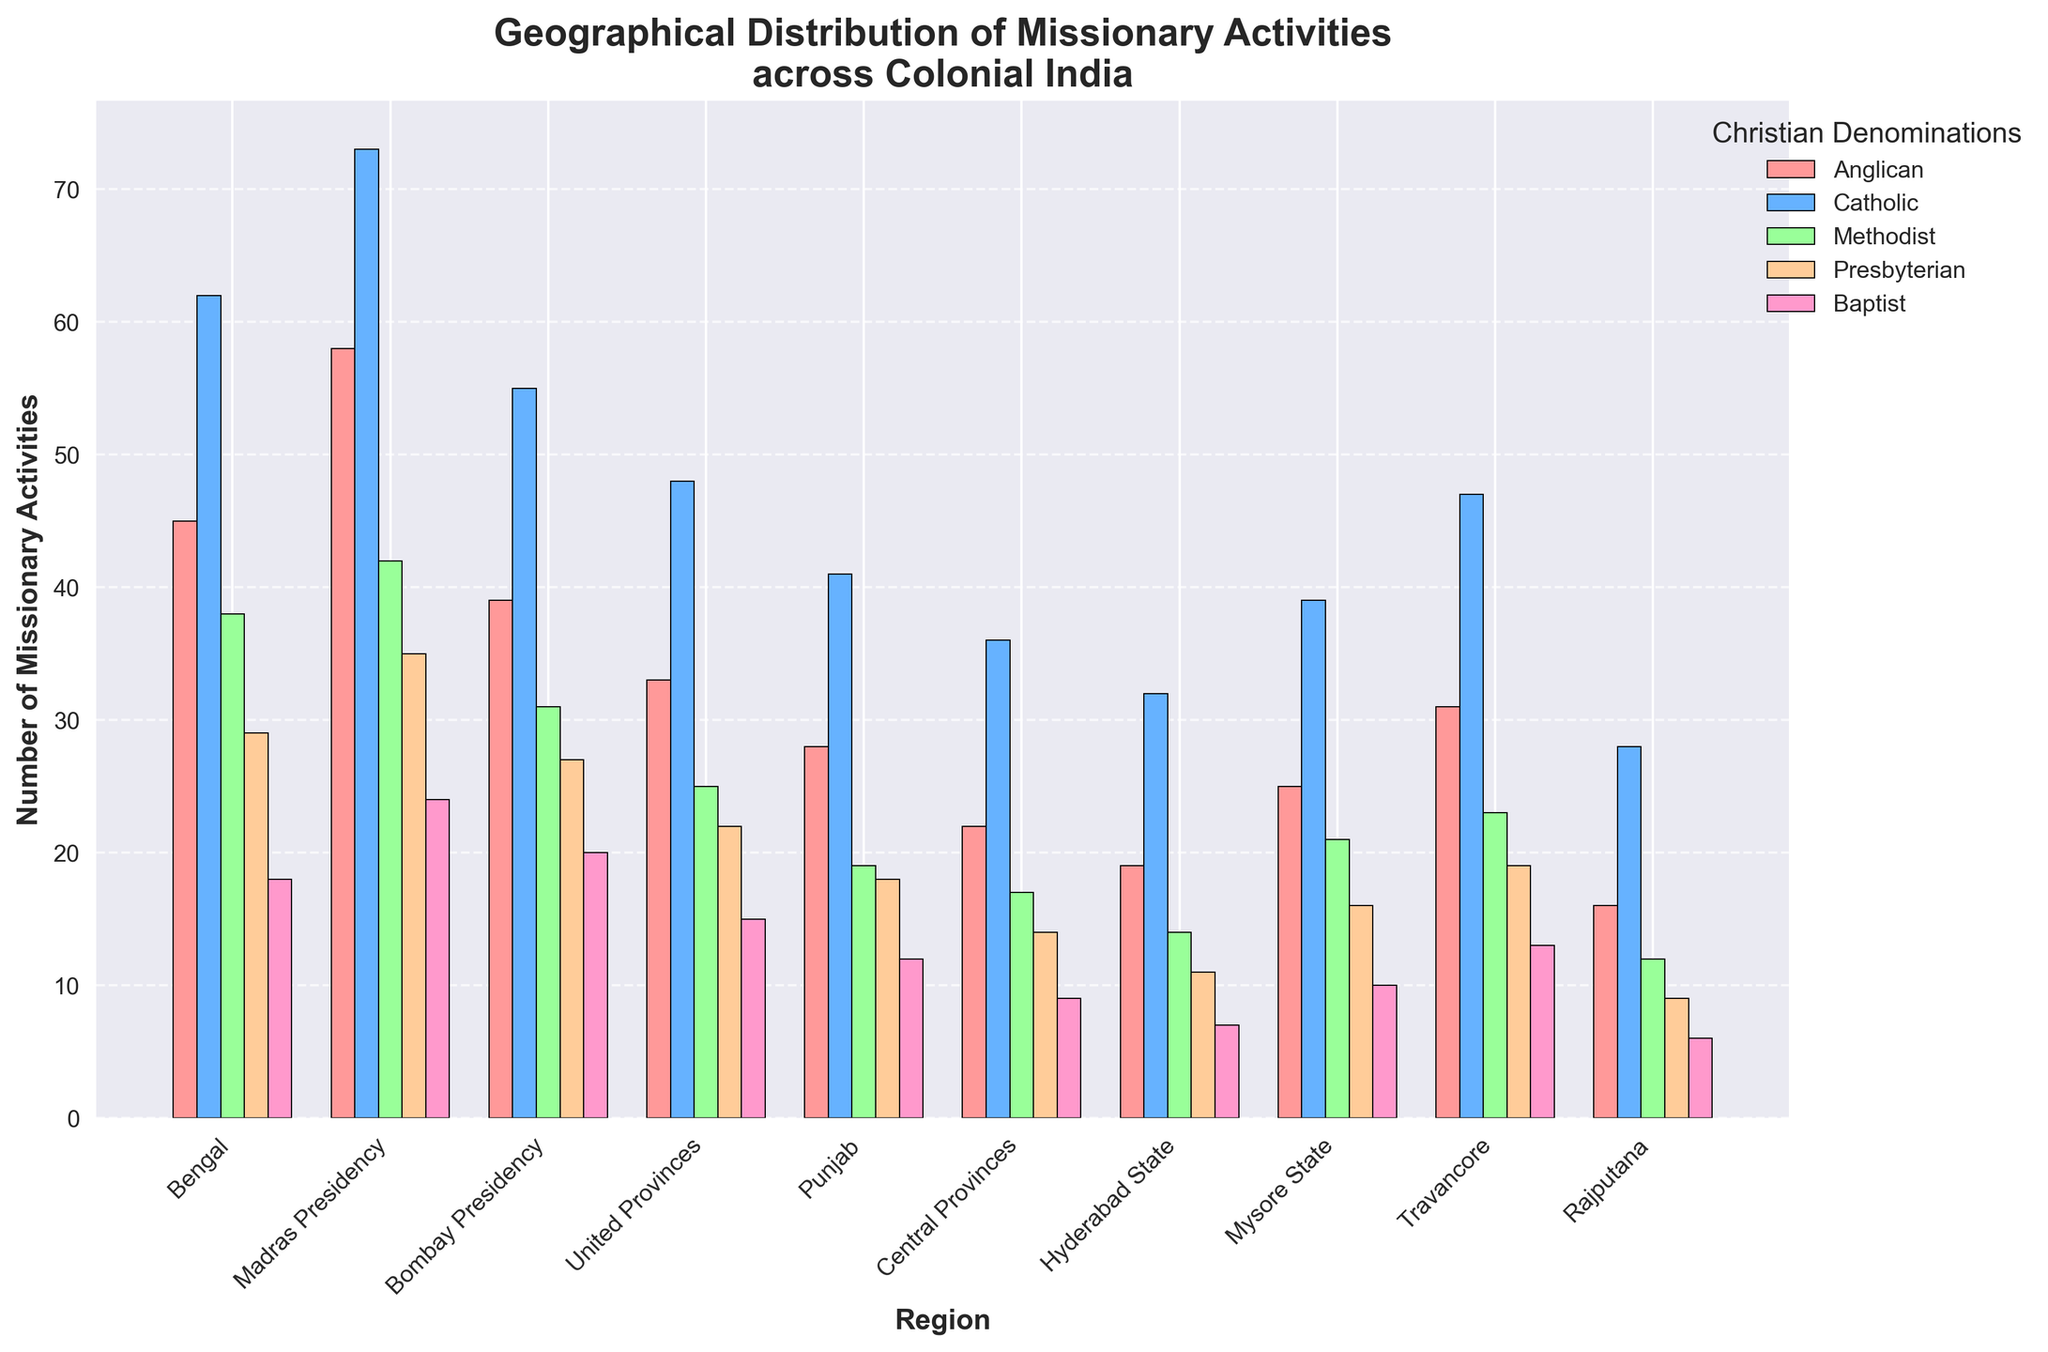Which region had the highest number of Catholic missionary activities? First, identify the bars representing Catholic missionary activities (blue color). Then compare their heights across all regions to find the tallest bar.
Answer: Madras Presidency How many more missionary activities did the Anglicans have in Bengal compared to the Presbyterians? Locate the bars for the Anglican (light red) and Presbyterian (light brown) denominations in Bengal. Compare the heights by subtracting the height of the Presbyterian bar from the Anglican bar. Anglican activities: 45, Presbyterian activities: 29. Calculate the difference: 45 - 29.
Answer: 16 Which denomination had the least missionary activities in Travancore? Identify all bars within the Travancore region and compare their heights to find the shortest one.
Answer: Baptist What is the total number of missionary activities by Methodists across all regions? Identify all the Methodist (light green) bars in each region and sum their values: 38+42+31+25+19+17+14+21+23+12. The calculation is 38 + 42 + 31 + 25 + 19 + 17 + 14 + 21 + 23 + 12.
Answer: 242 Comparing Punjab and United Provinces, which region had more Baptist missionary activities and by how much? Identify the Baptist (light pink) bars in both Punjab and United Provinces. Compare their heights and calculate the difference. Punjab: 12, United Provinces: 15. Difference: 15 - 12.
Answer: United Provinces by 3 Which region had Anglican missionary activities closest in number to those in the Mysore State? Identify the height of the Anglican bar in Mysore State (25), and locate other regions whose Anglican bars have similar heights. The closest heights are in Hyderabad State (19) and Central Provinces (22). Compare each to Mysore's 25.
Answer: Central Provinces What is the average number of missionary activities conducted by Presbyterians across all regions? Identify all the Presbyterian (orange) bars in each region and sum their values: 29+35+27+22+18+14+11+16+19+9. Divide the total by the number of regions to find the average: (29 + 35 + 27 + 22 + 18 + 14 + 11 + 16 + 19 + 9) / 10.
Answer: 20 Comparing Bengal and Madras Presidency, which region had more Methodist missionary activities and by how much? Identify and compare the heights of the Methodist (green) bars in Bengal (38) and Madras Presidency (42). Calculate the difference: 42 - 38.
Answer: Madras Presidency by 4 Which region had just one more Catholic missionary activity than the total number of Anglican missionary activities in Central Provinces? First, identify the number of Anglican activities in Central Provinces (22). Locate a region with exactly one more Catholic missionary activity (23).
Answer: Travancore In which region did the Baptist denomination have the same number of missionary activities as the Presbyterians in Rajputana? Find the number of Presbyterian activities in Rajputana (9) and identify the region with the same number for Baptists (9).
Answer: Central Provinces 